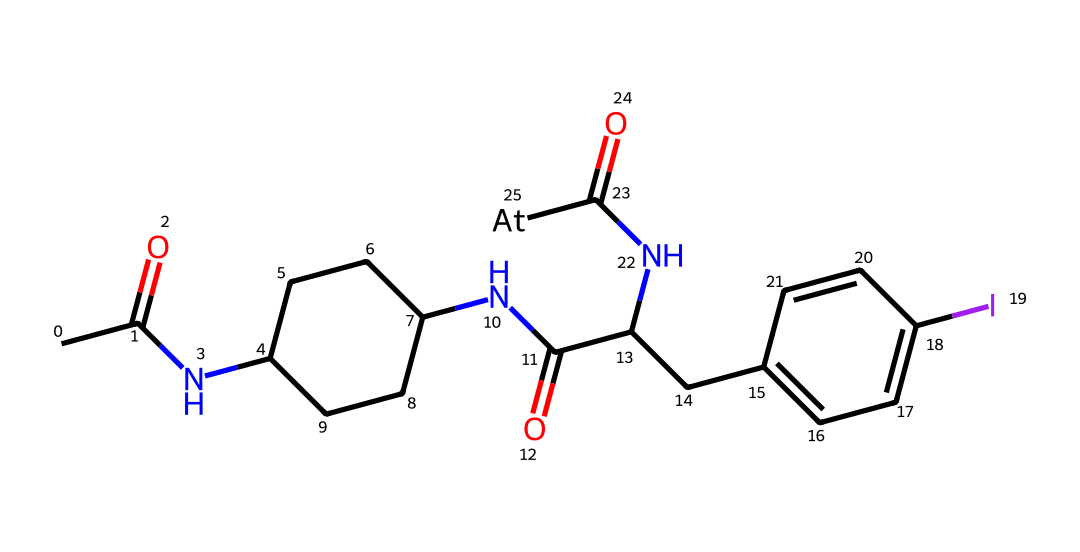What is the total number of nitrogen atoms in this structure? By examining the SMILES representation, we can count the nitrogen atoms signified by the symbol "N". The structure contains three distinct nitrogen atoms present in the amide functional groups.
Answer: three Which halogen is present in this chemical structure? In the provided SMILES, the symbol "I" represents iodine, indicating it is a halogen. Additionally, at the end, "[At]" indicates the presence of astatine. Astatine is also noted, being a member of the halogen group.
Answer: astatine How many carbon atoms are in this compound? By analyzing the SMILES representation, we can count the number of carbon atoms represented by the letter "C". There are a total of 17 carbon atoms in this chemical structure.
Answer: seventeen What type of chemical structure is represented here? The SMILES notation displays a complex organic compound containing amide linkages, which classifies it as a peptide-like structure. Additionally, it is labeled for radiopharmaceutical use.
Answer: peptide-like Which part of this molecule is responsible for its targeted cancer therapy properties? The segment containing the "[At]" label signifies the incorporation of astatine in the structure, which is essential for the radiopharmaceutical properties directly targeting cancer cells through a radiolytic mechanism.
Answer: astatine 